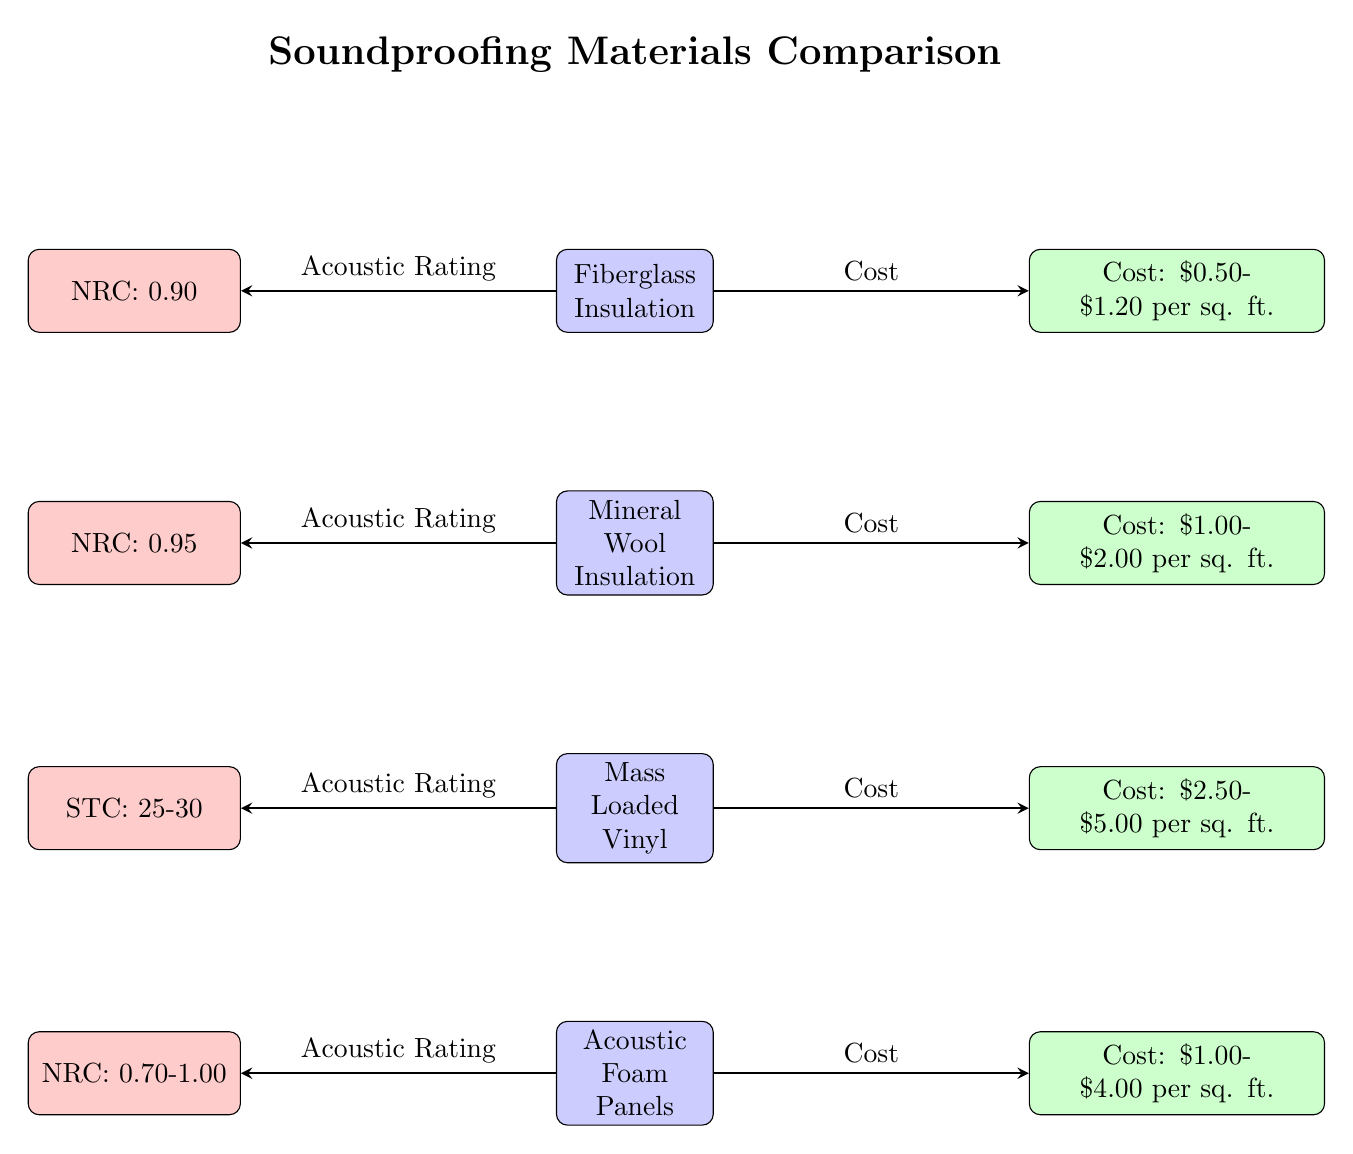What is the NRC rating for Fiberglass Insulation? The NRC rating for Fiberglass Insulation is displayed next to its node in the diagram. It is directly indicated as 0.90 beside the Fiberglass Insulation material.
Answer: NRC: 0.90 What is the cost range for Mass Loaded Vinyl? The cost range for Mass Loaded Vinyl is shown directly to the right of its node in the diagram. It indicates a range of $2.50 to $5.00 per square foot.
Answer: Cost: $2.50-$5.00 per sq. ft Which material has the highest NRC rating? To determine the material with the highest NRC rating, we compare the ratings: Fiberglass (0.90), Mineral Wool (0.95), and Acoustic Foam (0.70-1.00). Mineral Wool's NRC rating of 0.95 is the highest among them.
Answer: Mineral Wool Insulation What is the STC rating for Mass Loaded Vinyl? The STC rating for Mass Loaded Vinyl is indicated in the rating node next to its material node. It is listed as a range of 25-30, which describes its sound transmission class rating.
Answer: STC: 25-30 Which material has the lowest cost per square foot? By reviewing the cost information for each material, Fiberglass Insulation has the lowest cost range of $0.50 to $1.20 per square foot, which is less than the others.
Answer: $0.50-$1.20 per sq. ft 